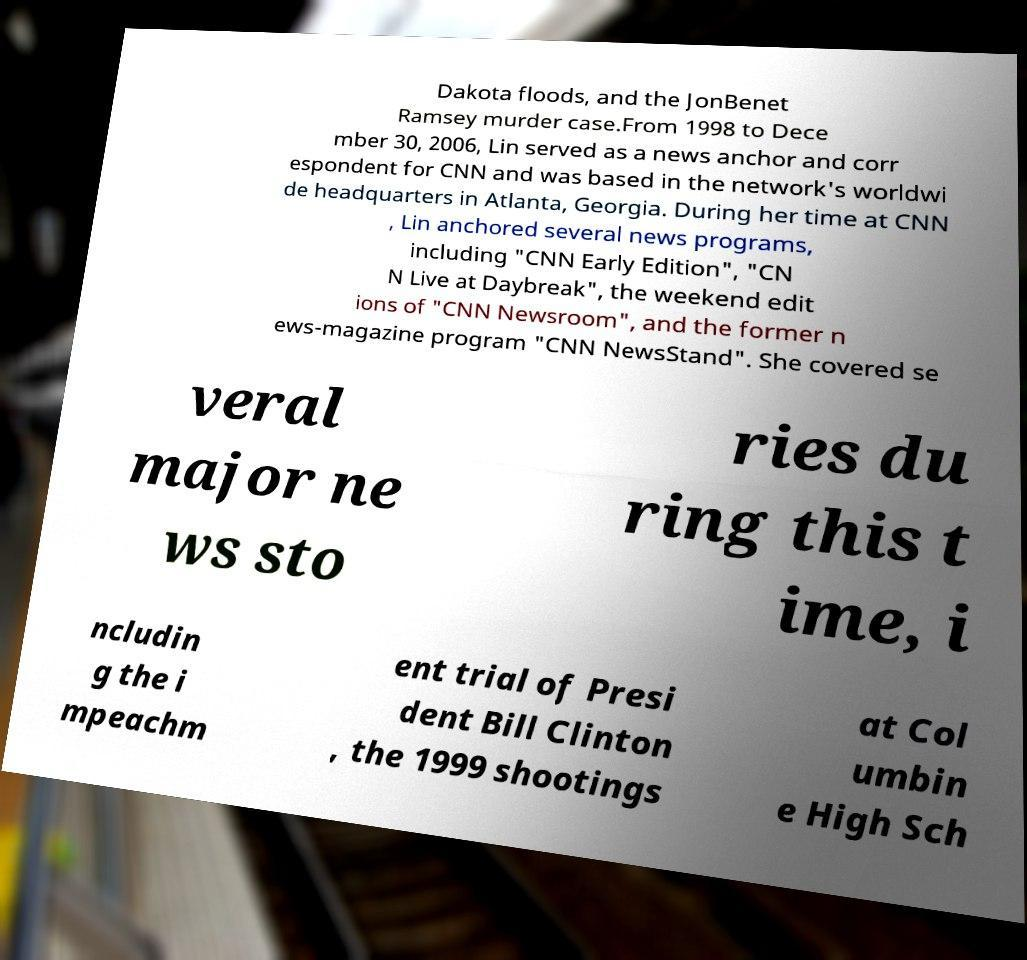Could you extract and type out the text from this image? Dakota floods, and the JonBenet Ramsey murder case.From 1998 to Dece mber 30, 2006, Lin served as a news anchor and corr espondent for CNN and was based in the network's worldwi de headquarters in Atlanta, Georgia. During her time at CNN , Lin anchored several news programs, including "CNN Early Edition", "CN N Live at Daybreak", the weekend edit ions of "CNN Newsroom", and the former n ews-magazine program "CNN NewsStand". She covered se veral major ne ws sto ries du ring this t ime, i ncludin g the i mpeachm ent trial of Presi dent Bill Clinton , the 1999 shootings at Col umbin e High Sch 